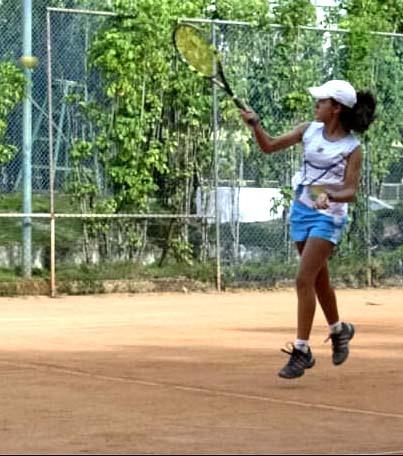What is on the woman's head?
Short answer required. Hat. Is the woman playing a sport?
Short answer required. Yes. Are her feet on the ground?
Concise answer only. No. What is the sex of the player playing the sport?
Answer briefly. Female. 